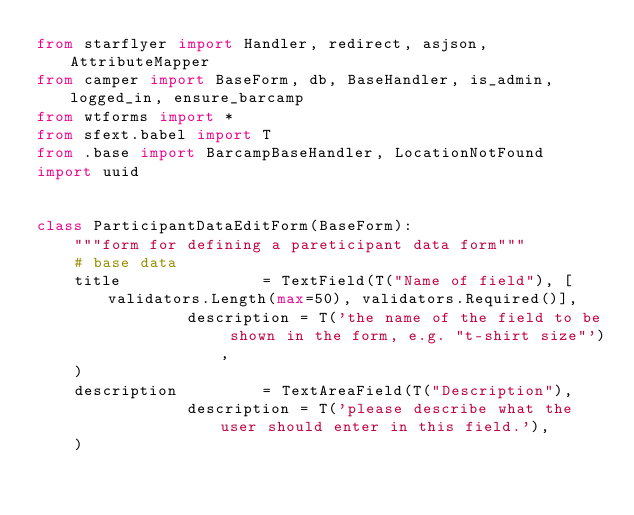<code> <loc_0><loc_0><loc_500><loc_500><_Python_>from starflyer import Handler, redirect, asjson, AttributeMapper
from camper import BaseForm, db, BaseHandler, is_admin, logged_in, ensure_barcamp
from wtforms import *
from sfext.babel import T
from .base import BarcampBaseHandler, LocationNotFound
import uuid


class ParticipantDataEditForm(BaseForm):
    """form for defining a pareticipant data form"""
    # base data
    title               = TextField(T("Name of field"), [validators.Length(max=50), validators.Required()],
                description = T('the name of the field to be shown in the form, e.g. "t-shirt size"'),
    )
    description         = TextAreaField(T("Description"),
                description = T('please describe what the user should enter in this field.'),
    )</code> 